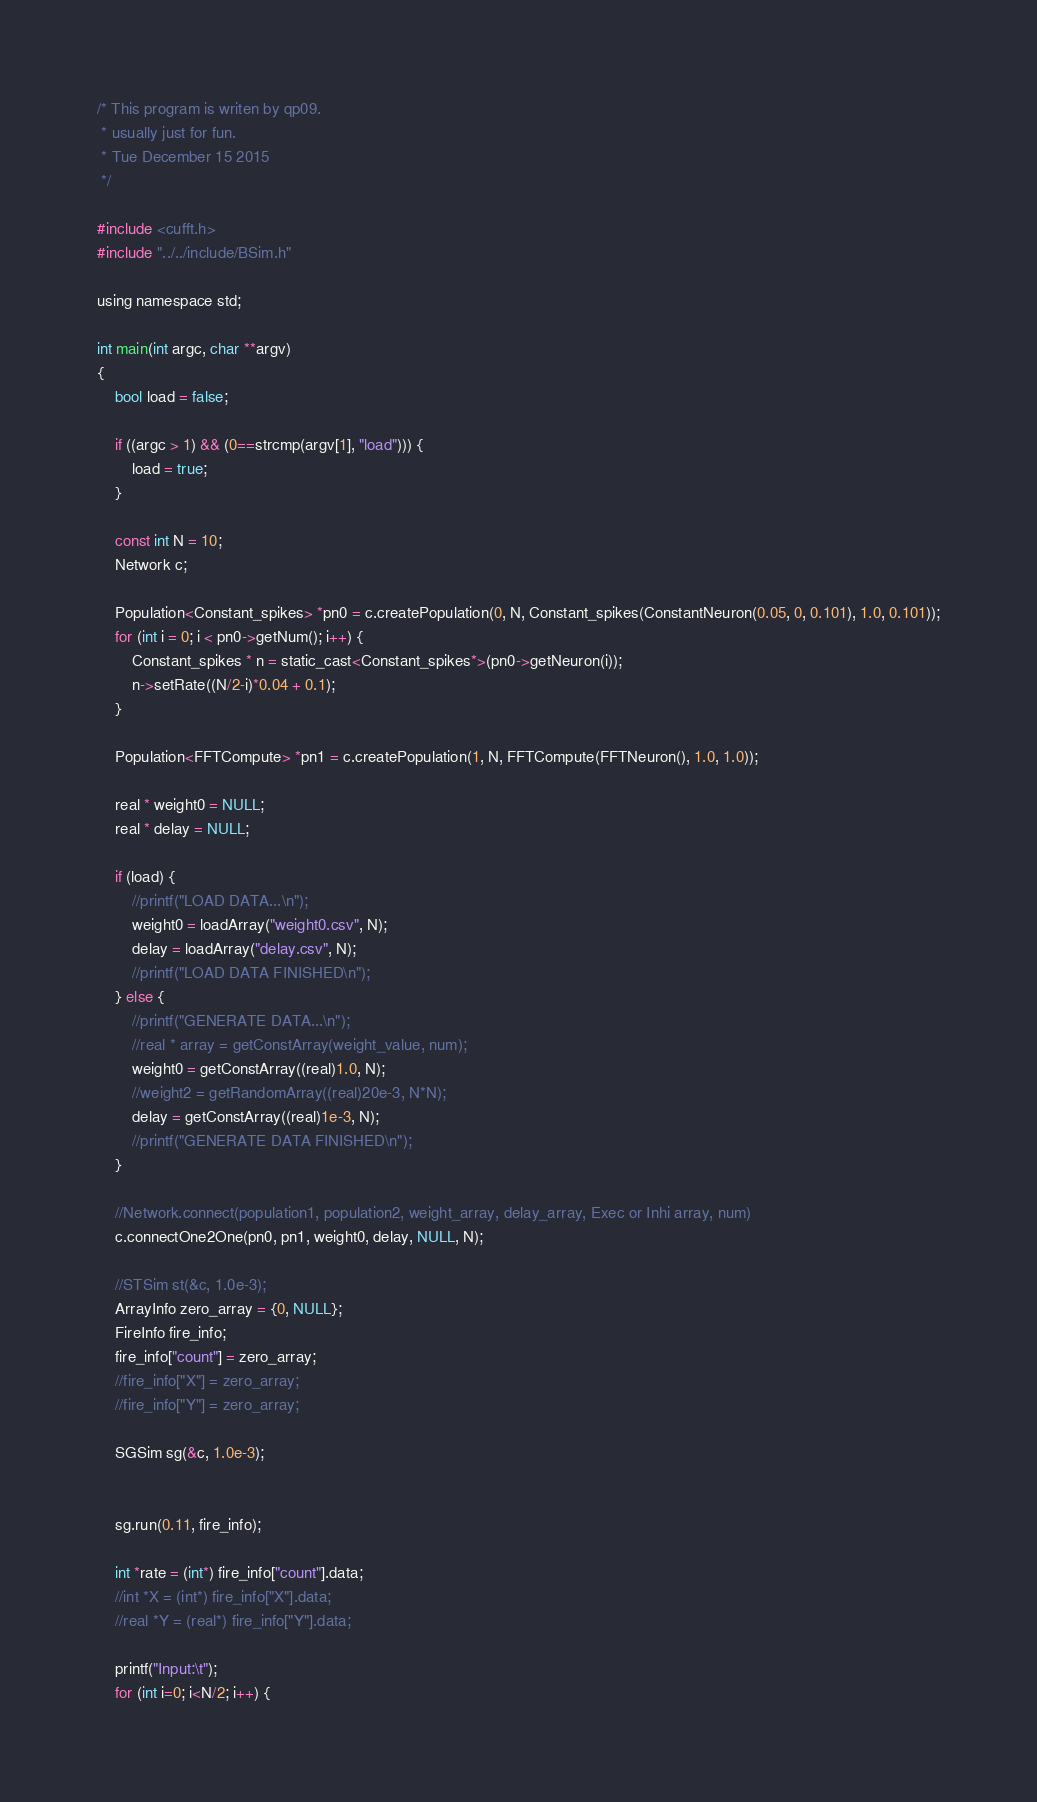<code> <loc_0><loc_0><loc_500><loc_500><_Cuda_>/* This program is writen by qp09.
 * usually just for fun.
 * Tue December 15 2015
 */

#include <cufft.h>
#include "../../include/BSim.h"

using namespace std;

int main(int argc, char **argv)
{
	bool load = false;

	if ((argc > 1) && (0==strcmp(argv[1], "load"))) {
		load = true;
	}

	const int N = 10;
	Network c;

	Population<Constant_spikes> *pn0 = c.createPopulation(0, N, Constant_spikes(ConstantNeuron(0.05, 0, 0.101), 1.0, 0.101));
	for (int i = 0; i < pn0->getNum(); i++) {
		Constant_spikes * n = static_cast<Constant_spikes*>(pn0->getNeuron(i));
		n->setRate((N/2-i)*0.04 + 0.1);
	}

	Population<FFTCompute> *pn1 = c.createPopulation(1, N, FFTCompute(FFTNeuron(), 1.0, 1.0));

	real * weight0 = NULL;
	real * delay = NULL;

	if (load) { 
		//printf("LOAD DATA...\n");
		weight0 = loadArray("weight0.csv", N);
		delay = loadArray("delay.csv", N);
		//printf("LOAD DATA FINISHED\n");
	} else {
		//printf("GENERATE DATA...\n");
		//real * array = getConstArray(weight_value, num);
		weight0 = getConstArray((real)1.0, N);
		//weight2 = getRandomArray((real)20e-3, N*N);
		delay = getConstArray((real)1e-3, N);
		//printf("GENERATE DATA FINISHED\n");
	}

	//Network.connect(population1, population2, weight_array, delay_array, Exec or Inhi array, num)
	c.connectOne2One(pn0, pn1, weight0, delay, NULL, N);

	//STSim st(&c, 1.0e-3);
	ArrayInfo zero_array = {0, NULL};
	FireInfo fire_info;
	fire_info["count"] = zero_array;
	//fire_info["X"] = zero_array;
	//fire_info["Y"] = zero_array;

	SGSim sg(&c, 1.0e-3);


	sg.run(0.11, fire_info);
	
	int *rate = (int*) fire_info["count"].data;
	//int *X = (int*) fire_info["X"].data;
	//real *Y = (real*) fire_info["Y"].data;

	printf("Input:\t");
	for (int i=0; i<N/2; i++) {</code> 